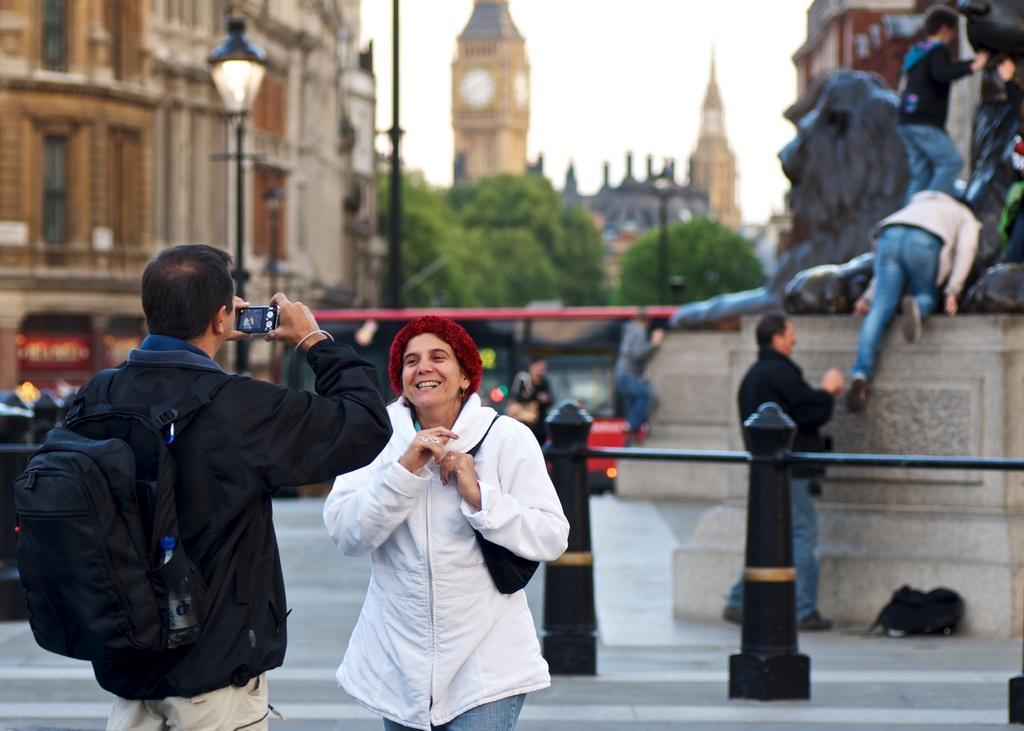Please provide a concise description of this image. In this image, there is an outside view. There is a person at the bottom of the image standing and wearing clothes. There is an another person on the left side of the image holding a camera with his hands. There is a sculpture and two persons in the top right of the image. There is a clock tower and sky at the top of the image. There is a building in the top left of the image. 